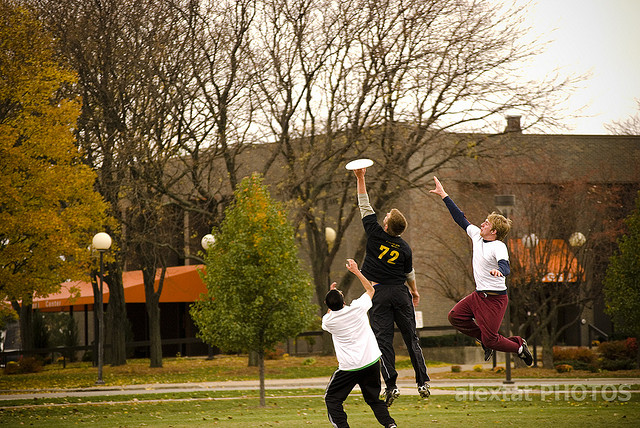What skills or qualities do these players need to demonstrate during the game? In the image, we witness a dynamic moment with three athletes in mid-action, vying for a soaring Frisbee. To excel in this game, the players need agility and speed to react swiftly and move quickly across the field. Coordination and precise timing are crucial to jump and catch the Frisbee effectively. Spatial awareness plays a significant role, helping players predict the trajectory of the Frisbee and position themselves strategically. Teamwork emerges as a vital element, fostering a cooperative environment where players must communicate effectively, both verbally and through body language, to coordinate their moves and strategize their plays. The intensity and passion evident in their efforts also point to a high level of commitment and competitive spirit which are essential for thriving in such a spirited game. 